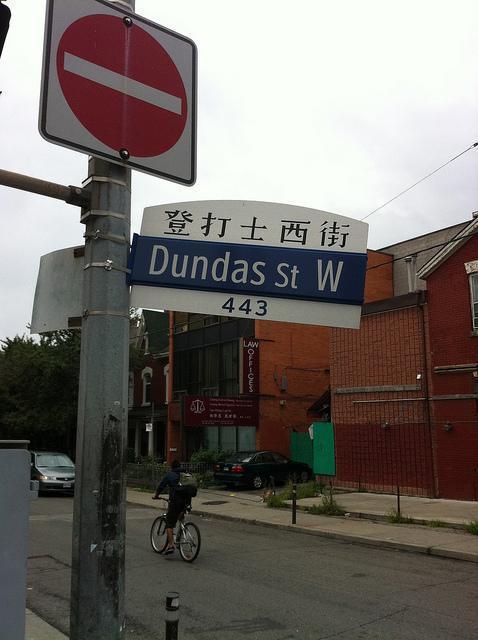How many signs are there?
Give a very brief answer. 2. 